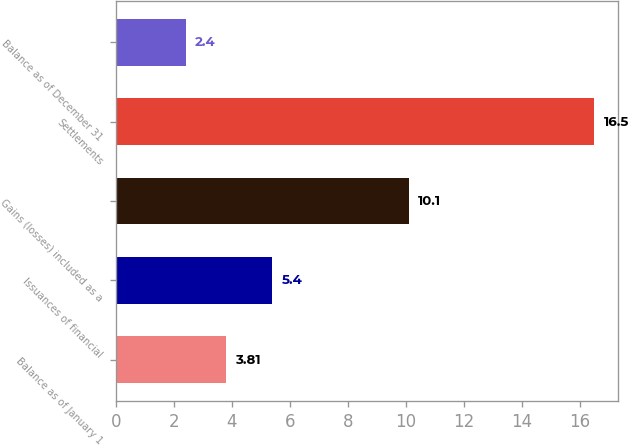<chart> <loc_0><loc_0><loc_500><loc_500><bar_chart><fcel>Balance as of January 1<fcel>Issuances of financial<fcel>Gains (losses) included as a<fcel>Settlements<fcel>Balance as of December 31<nl><fcel>3.81<fcel>5.4<fcel>10.1<fcel>16.5<fcel>2.4<nl></chart> 